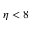<formula> <loc_0><loc_0><loc_500><loc_500>\eta < 8</formula> 